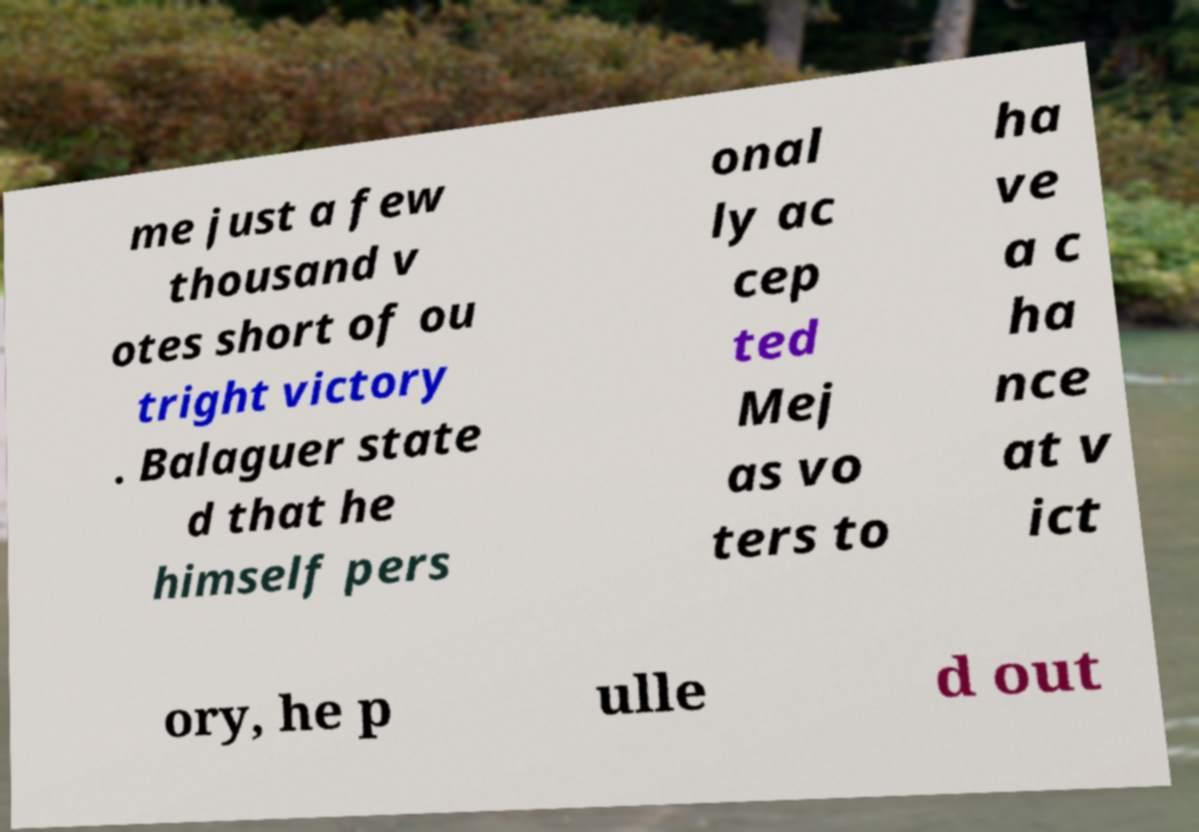Please identify and transcribe the text found in this image. me just a few thousand v otes short of ou tright victory . Balaguer state d that he himself pers onal ly ac cep ted Mej as vo ters to ha ve a c ha nce at v ict ory, he p ulle d out 